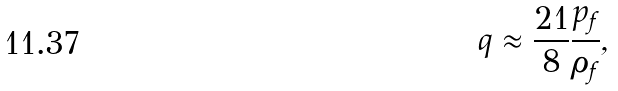<formula> <loc_0><loc_0><loc_500><loc_500>q \approx \frac { 2 1 } { 8 } \frac { p _ { f } } { \rho _ { f } } ,</formula> 